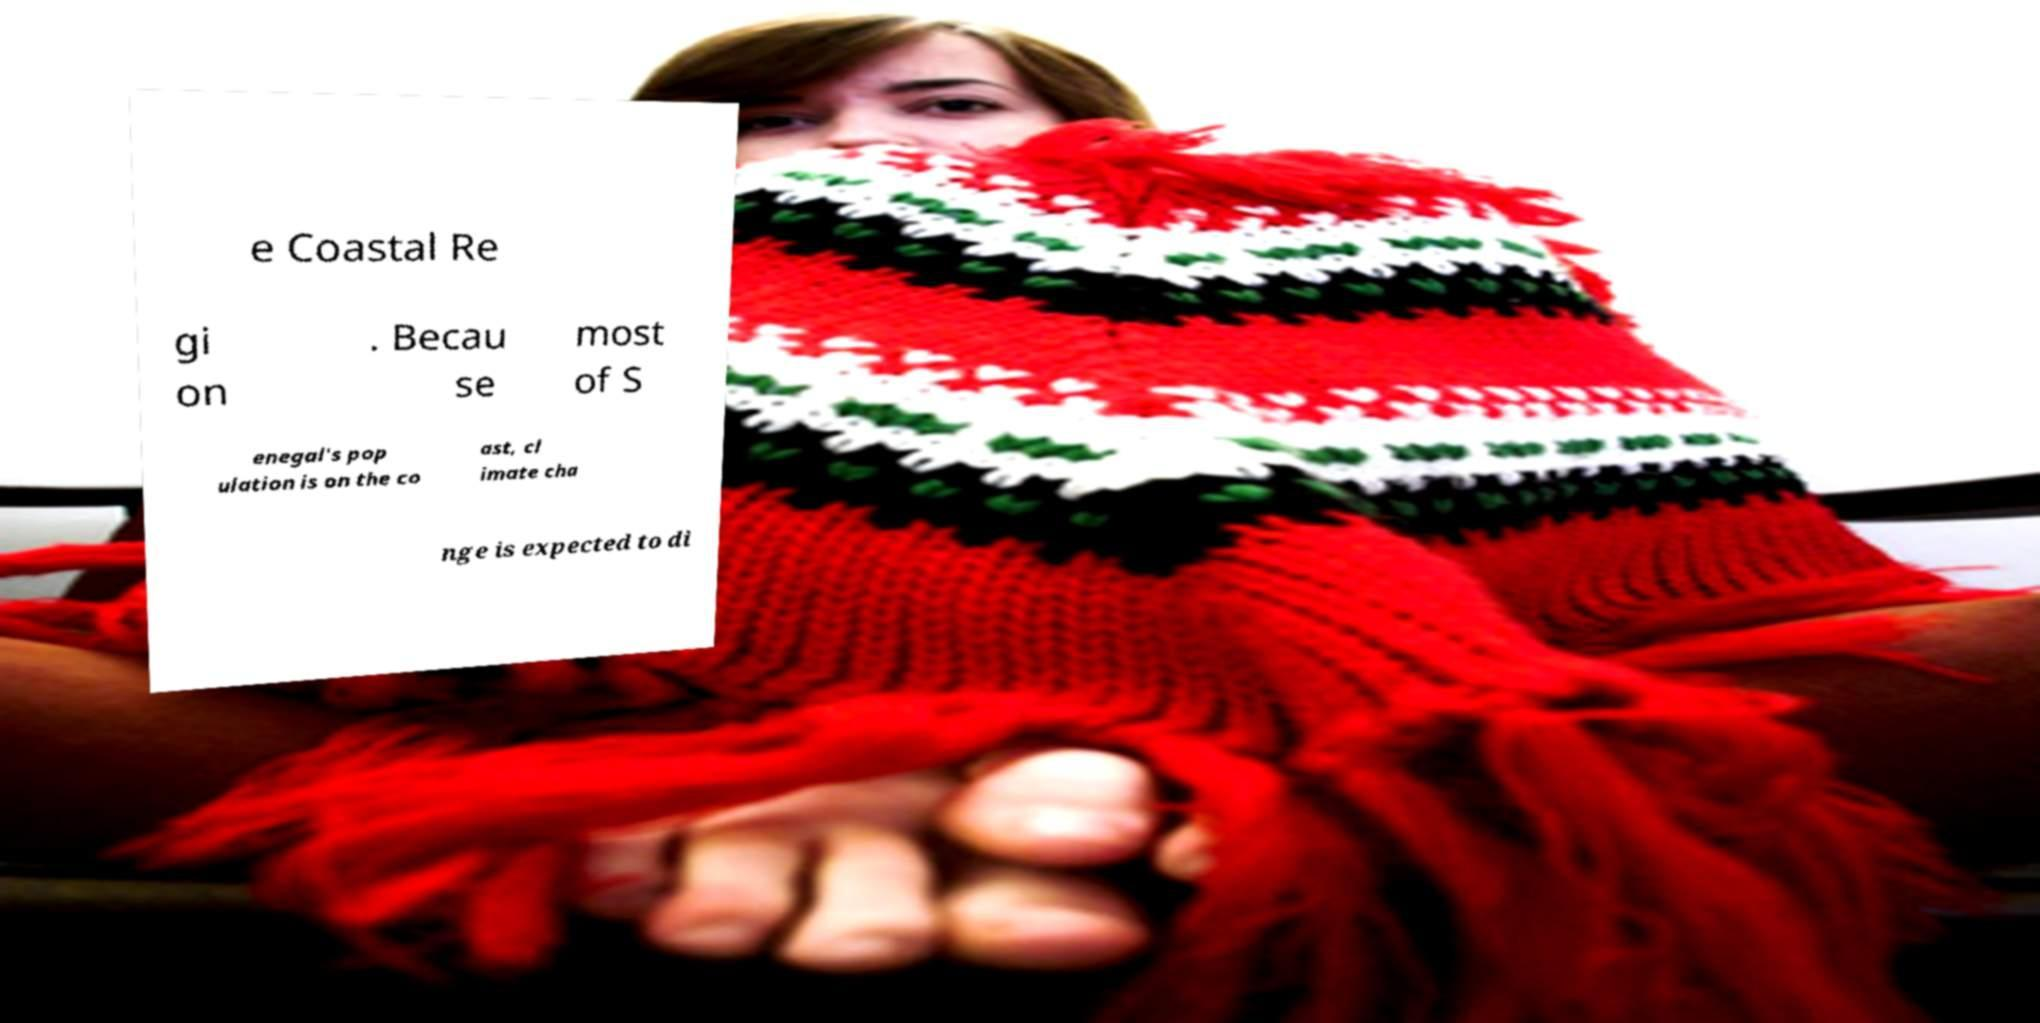What messages or text are displayed in this image? I need them in a readable, typed format. e Coastal Re gi on . Becau se most of S enegal's pop ulation is on the co ast, cl imate cha nge is expected to di 